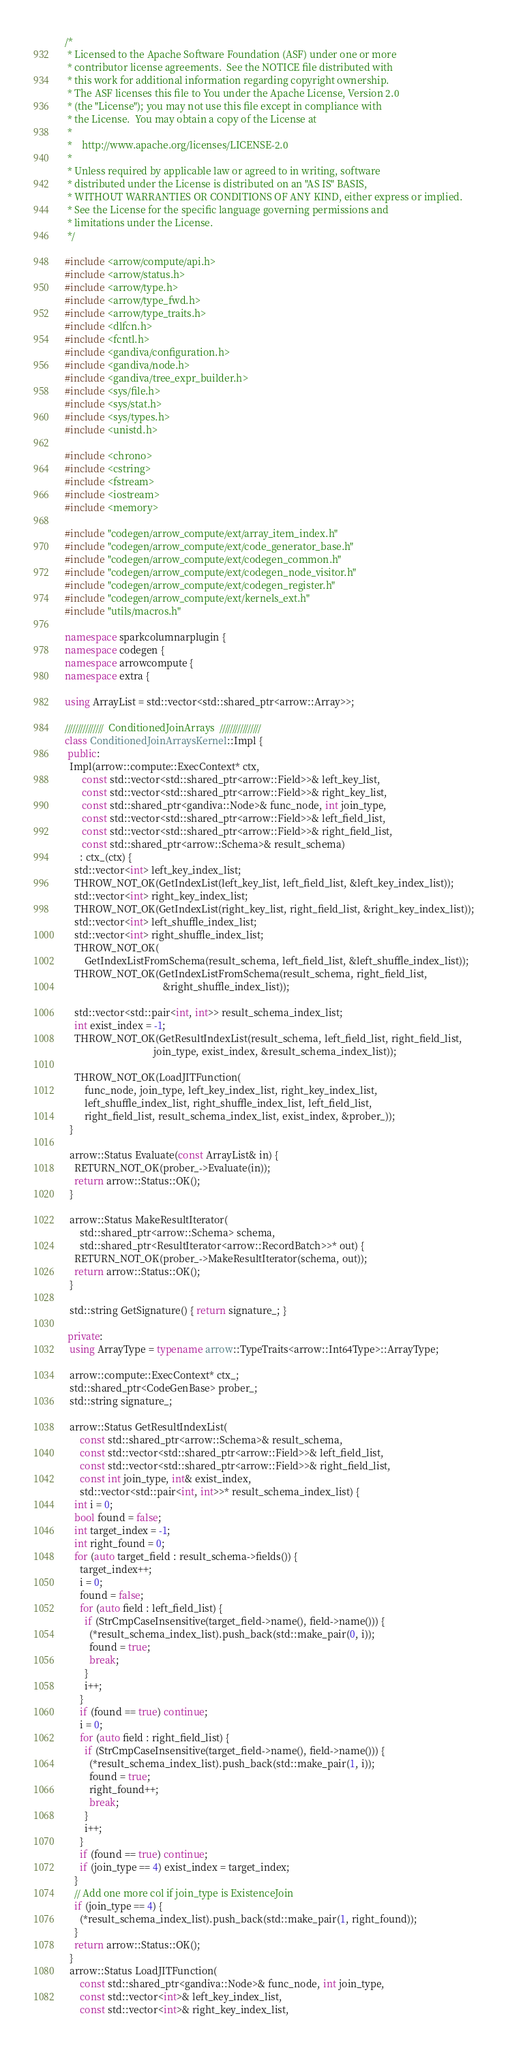Convert code to text. <code><loc_0><loc_0><loc_500><loc_500><_C++_>/*
 * Licensed to the Apache Software Foundation (ASF) under one or more
 * contributor license agreements.  See the NOTICE file distributed with
 * this work for additional information regarding copyright ownership.
 * The ASF licenses this file to You under the Apache License, Version 2.0
 * (the "License"); you may not use this file except in compliance with
 * the License.  You may obtain a copy of the License at
 *
 *    http://www.apache.org/licenses/LICENSE-2.0
 *
 * Unless required by applicable law or agreed to in writing, software
 * distributed under the License is distributed on an "AS IS" BASIS,
 * WITHOUT WARRANTIES OR CONDITIONS OF ANY KIND, either express or implied.
 * See the License for the specific language governing permissions and
 * limitations under the License.
 */

#include <arrow/compute/api.h>
#include <arrow/status.h>
#include <arrow/type.h>
#include <arrow/type_fwd.h>
#include <arrow/type_traits.h>
#include <dlfcn.h>
#include <fcntl.h>
#include <gandiva/configuration.h>
#include <gandiva/node.h>
#include <gandiva/tree_expr_builder.h>
#include <sys/file.h>
#include <sys/stat.h>
#include <sys/types.h>
#include <unistd.h>

#include <chrono>
#include <cstring>
#include <fstream>
#include <iostream>
#include <memory>

#include "codegen/arrow_compute/ext/array_item_index.h"
#include "codegen/arrow_compute/ext/code_generator_base.h"
#include "codegen/arrow_compute/ext/codegen_common.h"
#include "codegen/arrow_compute/ext/codegen_node_visitor.h"
#include "codegen/arrow_compute/ext/codegen_register.h"
#include "codegen/arrow_compute/ext/kernels_ext.h"
#include "utils/macros.h"

namespace sparkcolumnarplugin {
namespace codegen {
namespace arrowcompute {
namespace extra {

using ArrayList = std::vector<std::shared_ptr<arrow::Array>>;

///////////////  ConditionedJoinArrays  ////////////////
class ConditionedJoinArraysKernel::Impl {
 public:
  Impl(arrow::compute::ExecContext* ctx,
       const std::vector<std::shared_ptr<arrow::Field>>& left_key_list,
       const std::vector<std::shared_ptr<arrow::Field>>& right_key_list,
       const std::shared_ptr<gandiva::Node>& func_node, int join_type,
       const std::vector<std::shared_ptr<arrow::Field>>& left_field_list,
       const std::vector<std::shared_ptr<arrow::Field>>& right_field_list,
       const std::shared_ptr<arrow::Schema>& result_schema)
      : ctx_(ctx) {
    std::vector<int> left_key_index_list;
    THROW_NOT_OK(GetIndexList(left_key_list, left_field_list, &left_key_index_list));
    std::vector<int> right_key_index_list;
    THROW_NOT_OK(GetIndexList(right_key_list, right_field_list, &right_key_index_list));
    std::vector<int> left_shuffle_index_list;
    std::vector<int> right_shuffle_index_list;
    THROW_NOT_OK(
        GetIndexListFromSchema(result_schema, left_field_list, &left_shuffle_index_list));
    THROW_NOT_OK(GetIndexListFromSchema(result_schema, right_field_list,
                                        &right_shuffle_index_list));

    std::vector<std::pair<int, int>> result_schema_index_list;
    int exist_index = -1;
    THROW_NOT_OK(GetResultIndexList(result_schema, left_field_list, right_field_list,
                                    join_type, exist_index, &result_schema_index_list));

    THROW_NOT_OK(LoadJITFunction(
        func_node, join_type, left_key_index_list, right_key_index_list,
        left_shuffle_index_list, right_shuffle_index_list, left_field_list,
        right_field_list, result_schema_index_list, exist_index, &prober_));
  }

  arrow::Status Evaluate(const ArrayList& in) {
    RETURN_NOT_OK(prober_->Evaluate(in));
    return arrow::Status::OK();
  }

  arrow::Status MakeResultIterator(
      std::shared_ptr<arrow::Schema> schema,
      std::shared_ptr<ResultIterator<arrow::RecordBatch>>* out) {
    RETURN_NOT_OK(prober_->MakeResultIterator(schema, out));
    return arrow::Status::OK();
  }

  std::string GetSignature() { return signature_; }

 private:
  using ArrayType = typename arrow::TypeTraits<arrow::Int64Type>::ArrayType;

  arrow::compute::ExecContext* ctx_;
  std::shared_ptr<CodeGenBase> prober_;
  std::string signature_;

  arrow::Status GetResultIndexList(
      const std::shared_ptr<arrow::Schema>& result_schema,
      const std::vector<std::shared_ptr<arrow::Field>>& left_field_list,
      const std::vector<std::shared_ptr<arrow::Field>>& right_field_list,
      const int join_type, int& exist_index,
      std::vector<std::pair<int, int>>* result_schema_index_list) {
    int i = 0;
    bool found = false;
    int target_index = -1;
    int right_found = 0;
    for (auto target_field : result_schema->fields()) {
      target_index++;
      i = 0;
      found = false;
      for (auto field : left_field_list) {
        if (StrCmpCaseInsensitive(target_field->name(), field->name())) {
          (*result_schema_index_list).push_back(std::make_pair(0, i));
          found = true;
          break;
        }
        i++;
      }
      if (found == true) continue;
      i = 0;
      for (auto field : right_field_list) {
        if (StrCmpCaseInsensitive(target_field->name(), field->name())) {
          (*result_schema_index_list).push_back(std::make_pair(1, i));
          found = true;
          right_found++;
          break;
        }
        i++;
      }
      if (found == true) continue;
      if (join_type == 4) exist_index = target_index;
    }
    // Add one more col if join_type is ExistenceJoin
    if (join_type == 4) {
      (*result_schema_index_list).push_back(std::make_pair(1, right_found));
    }
    return arrow::Status::OK();
  }
  arrow::Status LoadJITFunction(
      const std::shared_ptr<gandiva::Node>& func_node, int join_type,
      const std::vector<int>& left_key_index_list,
      const std::vector<int>& right_key_index_list,</code> 